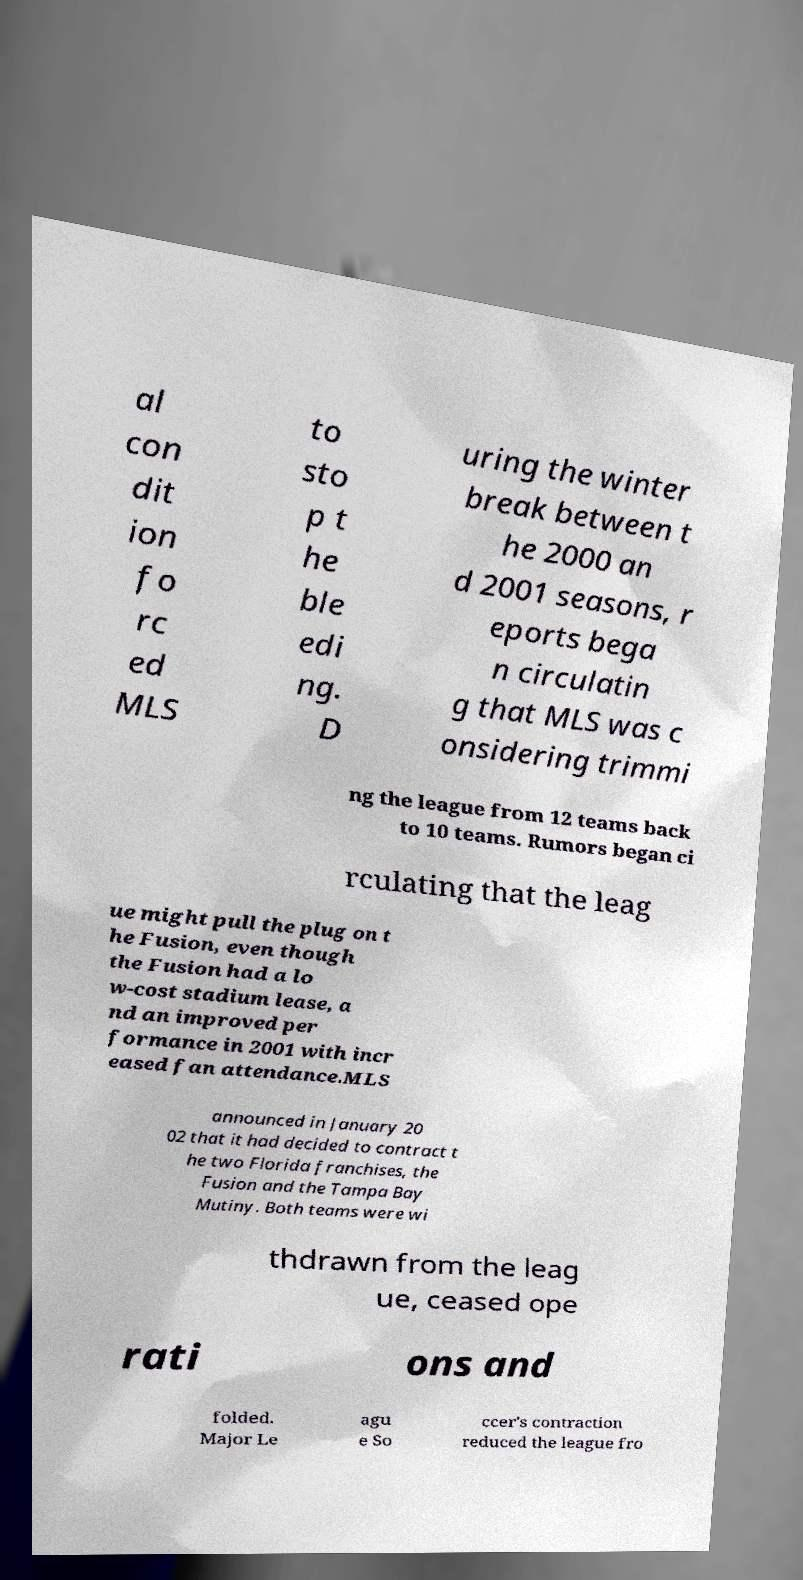Can you read and provide the text displayed in the image?This photo seems to have some interesting text. Can you extract and type it out for me? al con dit ion fo rc ed MLS to sto p t he ble edi ng. D uring the winter break between t he 2000 an d 2001 seasons, r eports bega n circulatin g that MLS was c onsidering trimmi ng the league from 12 teams back to 10 teams. Rumors began ci rculating that the leag ue might pull the plug on t he Fusion, even though the Fusion had a lo w-cost stadium lease, a nd an improved per formance in 2001 with incr eased fan attendance.MLS announced in January 20 02 that it had decided to contract t he two Florida franchises, the Fusion and the Tampa Bay Mutiny. Both teams were wi thdrawn from the leag ue, ceased ope rati ons and folded. Major Le agu e So ccer's contraction reduced the league fro 